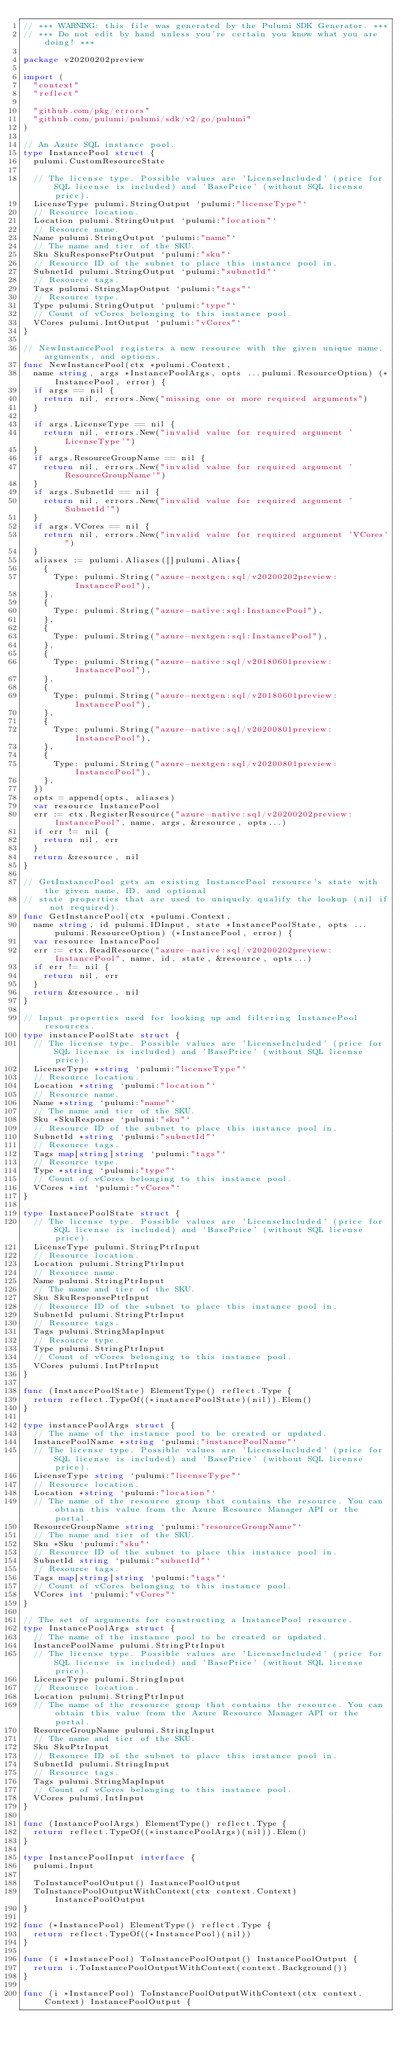<code> <loc_0><loc_0><loc_500><loc_500><_Go_>// *** WARNING: this file was generated by the Pulumi SDK Generator. ***
// *** Do not edit by hand unless you're certain you know what you are doing! ***

package v20200202preview

import (
	"context"
	"reflect"

	"github.com/pkg/errors"
	"github.com/pulumi/pulumi/sdk/v2/go/pulumi"
)

// An Azure SQL instance pool.
type InstancePool struct {
	pulumi.CustomResourceState

	// The license type. Possible values are 'LicenseIncluded' (price for SQL license is included) and 'BasePrice' (without SQL license price).
	LicenseType pulumi.StringOutput `pulumi:"licenseType"`
	// Resource location.
	Location pulumi.StringOutput `pulumi:"location"`
	// Resource name.
	Name pulumi.StringOutput `pulumi:"name"`
	// The name and tier of the SKU.
	Sku SkuResponsePtrOutput `pulumi:"sku"`
	// Resource ID of the subnet to place this instance pool in.
	SubnetId pulumi.StringOutput `pulumi:"subnetId"`
	// Resource tags.
	Tags pulumi.StringMapOutput `pulumi:"tags"`
	// Resource type.
	Type pulumi.StringOutput `pulumi:"type"`
	// Count of vCores belonging to this instance pool.
	VCores pulumi.IntOutput `pulumi:"vCores"`
}

// NewInstancePool registers a new resource with the given unique name, arguments, and options.
func NewInstancePool(ctx *pulumi.Context,
	name string, args *InstancePoolArgs, opts ...pulumi.ResourceOption) (*InstancePool, error) {
	if args == nil {
		return nil, errors.New("missing one or more required arguments")
	}

	if args.LicenseType == nil {
		return nil, errors.New("invalid value for required argument 'LicenseType'")
	}
	if args.ResourceGroupName == nil {
		return nil, errors.New("invalid value for required argument 'ResourceGroupName'")
	}
	if args.SubnetId == nil {
		return nil, errors.New("invalid value for required argument 'SubnetId'")
	}
	if args.VCores == nil {
		return nil, errors.New("invalid value for required argument 'VCores'")
	}
	aliases := pulumi.Aliases([]pulumi.Alias{
		{
			Type: pulumi.String("azure-nextgen:sql/v20200202preview:InstancePool"),
		},
		{
			Type: pulumi.String("azure-native:sql:InstancePool"),
		},
		{
			Type: pulumi.String("azure-nextgen:sql:InstancePool"),
		},
		{
			Type: pulumi.String("azure-native:sql/v20180601preview:InstancePool"),
		},
		{
			Type: pulumi.String("azure-nextgen:sql/v20180601preview:InstancePool"),
		},
		{
			Type: pulumi.String("azure-native:sql/v20200801preview:InstancePool"),
		},
		{
			Type: pulumi.String("azure-nextgen:sql/v20200801preview:InstancePool"),
		},
	})
	opts = append(opts, aliases)
	var resource InstancePool
	err := ctx.RegisterResource("azure-native:sql/v20200202preview:InstancePool", name, args, &resource, opts...)
	if err != nil {
		return nil, err
	}
	return &resource, nil
}

// GetInstancePool gets an existing InstancePool resource's state with the given name, ID, and optional
// state properties that are used to uniquely qualify the lookup (nil if not required).
func GetInstancePool(ctx *pulumi.Context,
	name string, id pulumi.IDInput, state *InstancePoolState, opts ...pulumi.ResourceOption) (*InstancePool, error) {
	var resource InstancePool
	err := ctx.ReadResource("azure-native:sql/v20200202preview:InstancePool", name, id, state, &resource, opts...)
	if err != nil {
		return nil, err
	}
	return &resource, nil
}

// Input properties used for looking up and filtering InstancePool resources.
type instancePoolState struct {
	// The license type. Possible values are 'LicenseIncluded' (price for SQL license is included) and 'BasePrice' (without SQL license price).
	LicenseType *string `pulumi:"licenseType"`
	// Resource location.
	Location *string `pulumi:"location"`
	// Resource name.
	Name *string `pulumi:"name"`
	// The name and tier of the SKU.
	Sku *SkuResponse `pulumi:"sku"`
	// Resource ID of the subnet to place this instance pool in.
	SubnetId *string `pulumi:"subnetId"`
	// Resource tags.
	Tags map[string]string `pulumi:"tags"`
	// Resource type.
	Type *string `pulumi:"type"`
	// Count of vCores belonging to this instance pool.
	VCores *int `pulumi:"vCores"`
}

type InstancePoolState struct {
	// The license type. Possible values are 'LicenseIncluded' (price for SQL license is included) and 'BasePrice' (without SQL license price).
	LicenseType pulumi.StringPtrInput
	// Resource location.
	Location pulumi.StringPtrInput
	// Resource name.
	Name pulumi.StringPtrInput
	// The name and tier of the SKU.
	Sku SkuResponsePtrInput
	// Resource ID of the subnet to place this instance pool in.
	SubnetId pulumi.StringPtrInput
	// Resource tags.
	Tags pulumi.StringMapInput
	// Resource type.
	Type pulumi.StringPtrInput
	// Count of vCores belonging to this instance pool.
	VCores pulumi.IntPtrInput
}

func (InstancePoolState) ElementType() reflect.Type {
	return reflect.TypeOf((*instancePoolState)(nil)).Elem()
}

type instancePoolArgs struct {
	// The name of the instance pool to be created or updated.
	InstancePoolName *string `pulumi:"instancePoolName"`
	// The license type. Possible values are 'LicenseIncluded' (price for SQL license is included) and 'BasePrice' (without SQL license price).
	LicenseType string `pulumi:"licenseType"`
	// Resource location.
	Location *string `pulumi:"location"`
	// The name of the resource group that contains the resource. You can obtain this value from the Azure Resource Manager API or the portal.
	ResourceGroupName string `pulumi:"resourceGroupName"`
	// The name and tier of the SKU.
	Sku *Sku `pulumi:"sku"`
	// Resource ID of the subnet to place this instance pool in.
	SubnetId string `pulumi:"subnetId"`
	// Resource tags.
	Tags map[string]string `pulumi:"tags"`
	// Count of vCores belonging to this instance pool.
	VCores int `pulumi:"vCores"`
}

// The set of arguments for constructing a InstancePool resource.
type InstancePoolArgs struct {
	// The name of the instance pool to be created or updated.
	InstancePoolName pulumi.StringPtrInput
	// The license type. Possible values are 'LicenseIncluded' (price for SQL license is included) and 'BasePrice' (without SQL license price).
	LicenseType pulumi.StringInput
	// Resource location.
	Location pulumi.StringPtrInput
	// The name of the resource group that contains the resource. You can obtain this value from the Azure Resource Manager API or the portal.
	ResourceGroupName pulumi.StringInput
	// The name and tier of the SKU.
	Sku SkuPtrInput
	// Resource ID of the subnet to place this instance pool in.
	SubnetId pulumi.StringInput
	// Resource tags.
	Tags pulumi.StringMapInput
	// Count of vCores belonging to this instance pool.
	VCores pulumi.IntInput
}

func (InstancePoolArgs) ElementType() reflect.Type {
	return reflect.TypeOf((*instancePoolArgs)(nil)).Elem()
}

type InstancePoolInput interface {
	pulumi.Input

	ToInstancePoolOutput() InstancePoolOutput
	ToInstancePoolOutputWithContext(ctx context.Context) InstancePoolOutput
}

func (*InstancePool) ElementType() reflect.Type {
	return reflect.TypeOf((*InstancePool)(nil))
}

func (i *InstancePool) ToInstancePoolOutput() InstancePoolOutput {
	return i.ToInstancePoolOutputWithContext(context.Background())
}

func (i *InstancePool) ToInstancePoolOutputWithContext(ctx context.Context) InstancePoolOutput {</code> 